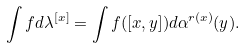<formula> <loc_0><loc_0><loc_500><loc_500>\int f d \lambda ^ { [ x ] } = \int f ( [ x , y ] ) d \alpha ^ { r ( x ) } ( y ) .</formula> 